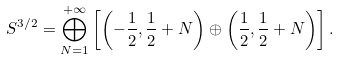<formula> <loc_0><loc_0><loc_500><loc_500>S ^ { 3 / 2 } = \bigoplus _ { N = 1 } ^ { + \infty } \left [ \left ( - \frac { 1 } { 2 } , \frac { 1 } { 2 } + N \right ) \oplus \left ( \frac { 1 } { 2 } , \frac { 1 } { 2 } + N \right ) \right ] .</formula> 